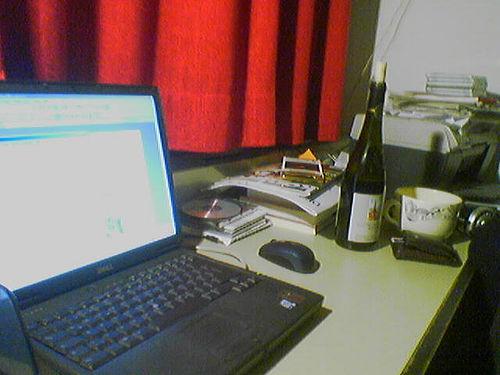Is the laptop too close to the edge?
Give a very brief answer. No. What brand is the laptop?
Be succinct. Dell. Is there a cup on the desk?
Concise answer only. Yes. Can the ink on the keys wear off?
Short answer required. Yes. 